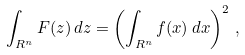<formula> <loc_0><loc_0><loc_500><loc_500>\int _ { { R } ^ { n } } F ( z ) \, d z = \left ( \int _ { { R } ^ { n } } f ( x ) \, d x \right ) ^ { 2 } \, ,</formula> 